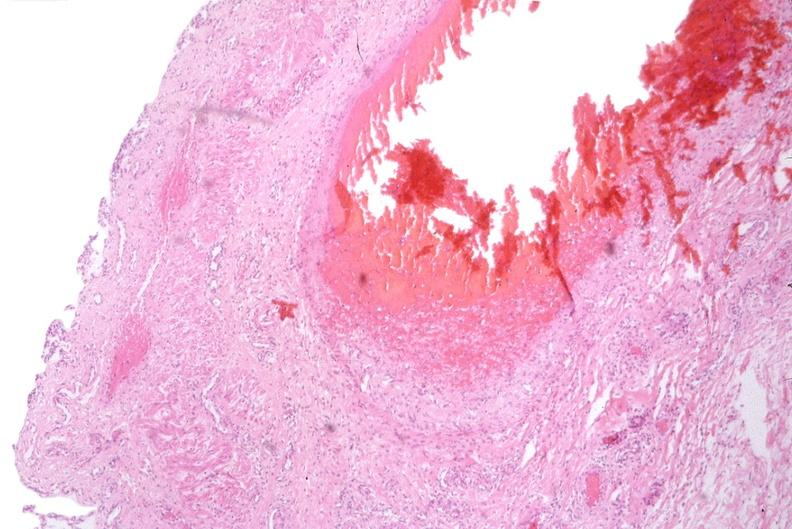s intrauterine contraceptive device present?
Answer the question using a single word or phrase. No 